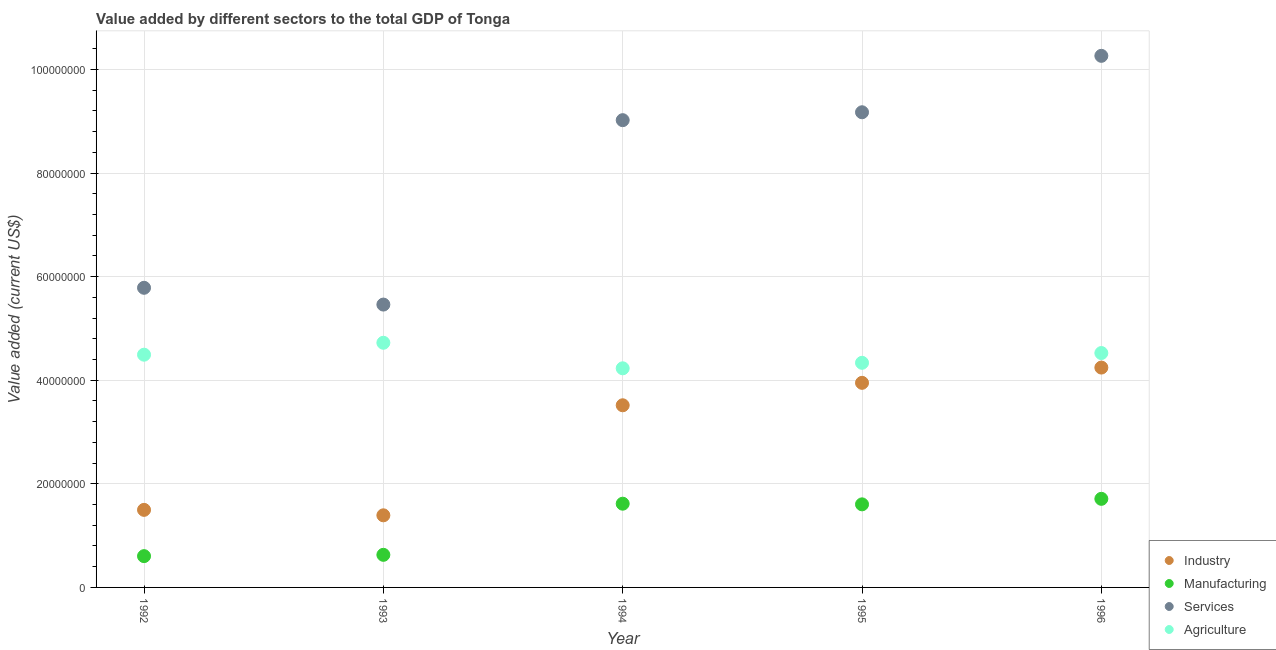How many different coloured dotlines are there?
Keep it short and to the point. 4. What is the value added by manufacturing sector in 1992?
Provide a short and direct response. 6.04e+06. Across all years, what is the maximum value added by industrial sector?
Offer a terse response. 4.25e+07. Across all years, what is the minimum value added by industrial sector?
Provide a succinct answer. 1.39e+07. What is the total value added by manufacturing sector in the graph?
Ensure brevity in your answer.  6.16e+07. What is the difference between the value added by industrial sector in 1993 and that in 1996?
Make the answer very short. -2.85e+07. What is the difference between the value added by services sector in 1996 and the value added by manufacturing sector in 1995?
Offer a terse response. 8.66e+07. What is the average value added by services sector per year?
Your answer should be very brief. 7.94e+07. In the year 1992, what is the difference between the value added by agricultural sector and value added by services sector?
Provide a short and direct response. -1.29e+07. In how many years, is the value added by manufacturing sector greater than 20000000 US$?
Provide a succinct answer. 0. What is the ratio of the value added by industrial sector in 1993 to that in 1994?
Provide a short and direct response. 0.4. Is the value added by agricultural sector in 1992 less than that in 1995?
Offer a terse response. No. Is the difference between the value added by manufacturing sector in 1992 and 1995 greater than the difference between the value added by services sector in 1992 and 1995?
Your answer should be very brief. Yes. What is the difference between the highest and the second highest value added by agricultural sector?
Provide a short and direct response. 1.98e+06. What is the difference between the highest and the lowest value added by industrial sector?
Provide a short and direct response. 2.85e+07. Is the sum of the value added by manufacturing sector in 1992 and 1994 greater than the maximum value added by agricultural sector across all years?
Ensure brevity in your answer.  No. Is it the case that in every year, the sum of the value added by services sector and value added by industrial sector is greater than the sum of value added by agricultural sector and value added by manufacturing sector?
Offer a terse response. No. Is it the case that in every year, the sum of the value added by industrial sector and value added by manufacturing sector is greater than the value added by services sector?
Offer a terse response. No. Is the value added by services sector strictly greater than the value added by industrial sector over the years?
Your answer should be very brief. Yes. Does the graph contain any zero values?
Your answer should be compact. No. Where does the legend appear in the graph?
Give a very brief answer. Bottom right. What is the title of the graph?
Give a very brief answer. Value added by different sectors to the total GDP of Tonga. Does "Second 20% of population" appear as one of the legend labels in the graph?
Provide a succinct answer. No. What is the label or title of the X-axis?
Ensure brevity in your answer.  Year. What is the label or title of the Y-axis?
Offer a terse response. Value added (current US$). What is the Value added (current US$) in Industry in 1992?
Your response must be concise. 1.50e+07. What is the Value added (current US$) in Manufacturing in 1992?
Provide a succinct answer. 6.04e+06. What is the Value added (current US$) of Services in 1992?
Provide a succinct answer. 5.79e+07. What is the Value added (current US$) of Agriculture in 1992?
Your answer should be compact. 4.49e+07. What is the Value added (current US$) of Industry in 1993?
Provide a succinct answer. 1.39e+07. What is the Value added (current US$) of Manufacturing in 1993?
Make the answer very short. 6.29e+06. What is the Value added (current US$) of Services in 1993?
Your answer should be very brief. 5.46e+07. What is the Value added (current US$) in Agriculture in 1993?
Offer a very short reply. 4.72e+07. What is the Value added (current US$) of Industry in 1994?
Ensure brevity in your answer.  3.52e+07. What is the Value added (current US$) of Manufacturing in 1994?
Your response must be concise. 1.62e+07. What is the Value added (current US$) in Services in 1994?
Ensure brevity in your answer.  9.02e+07. What is the Value added (current US$) of Agriculture in 1994?
Offer a terse response. 4.23e+07. What is the Value added (current US$) of Industry in 1995?
Keep it short and to the point. 3.95e+07. What is the Value added (current US$) of Manufacturing in 1995?
Your response must be concise. 1.60e+07. What is the Value added (current US$) of Services in 1995?
Provide a short and direct response. 9.17e+07. What is the Value added (current US$) in Agriculture in 1995?
Provide a succinct answer. 4.34e+07. What is the Value added (current US$) in Industry in 1996?
Your answer should be compact. 4.25e+07. What is the Value added (current US$) of Manufacturing in 1996?
Your answer should be very brief. 1.71e+07. What is the Value added (current US$) of Services in 1996?
Your response must be concise. 1.03e+08. What is the Value added (current US$) of Agriculture in 1996?
Your response must be concise. 4.53e+07. Across all years, what is the maximum Value added (current US$) in Industry?
Your answer should be compact. 4.25e+07. Across all years, what is the maximum Value added (current US$) of Manufacturing?
Give a very brief answer. 1.71e+07. Across all years, what is the maximum Value added (current US$) of Services?
Your answer should be compact. 1.03e+08. Across all years, what is the maximum Value added (current US$) of Agriculture?
Offer a very short reply. 4.72e+07. Across all years, what is the minimum Value added (current US$) in Industry?
Your response must be concise. 1.39e+07. Across all years, what is the minimum Value added (current US$) of Manufacturing?
Your response must be concise. 6.04e+06. Across all years, what is the minimum Value added (current US$) in Services?
Offer a very short reply. 5.46e+07. Across all years, what is the minimum Value added (current US$) of Agriculture?
Give a very brief answer. 4.23e+07. What is the total Value added (current US$) in Industry in the graph?
Provide a short and direct response. 1.46e+08. What is the total Value added (current US$) in Manufacturing in the graph?
Your answer should be compact. 6.16e+07. What is the total Value added (current US$) in Services in the graph?
Your response must be concise. 3.97e+08. What is the total Value added (current US$) in Agriculture in the graph?
Provide a short and direct response. 2.23e+08. What is the difference between the Value added (current US$) of Industry in 1992 and that in 1993?
Offer a terse response. 1.05e+06. What is the difference between the Value added (current US$) of Manufacturing in 1992 and that in 1993?
Offer a terse response. -2.51e+05. What is the difference between the Value added (current US$) of Services in 1992 and that in 1993?
Offer a very short reply. 3.24e+06. What is the difference between the Value added (current US$) in Agriculture in 1992 and that in 1993?
Provide a succinct answer. -2.30e+06. What is the difference between the Value added (current US$) of Industry in 1992 and that in 1994?
Provide a succinct answer. -2.02e+07. What is the difference between the Value added (current US$) in Manufacturing in 1992 and that in 1994?
Give a very brief answer. -1.01e+07. What is the difference between the Value added (current US$) of Services in 1992 and that in 1994?
Make the answer very short. -3.24e+07. What is the difference between the Value added (current US$) in Agriculture in 1992 and that in 1994?
Your answer should be very brief. 2.63e+06. What is the difference between the Value added (current US$) in Industry in 1992 and that in 1995?
Provide a short and direct response. -2.45e+07. What is the difference between the Value added (current US$) in Manufacturing in 1992 and that in 1995?
Give a very brief answer. -1.00e+07. What is the difference between the Value added (current US$) in Services in 1992 and that in 1995?
Your response must be concise. -3.39e+07. What is the difference between the Value added (current US$) in Agriculture in 1992 and that in 1995?
Provide a succinct answer. 1.57e+06. What is the difference between the Value added (current US$) of Industry in 1992 and that in 1996?
Ensure brevity in your answer.  -2.75e+07. What is the difference between the Value added (current US$) of Manufacturing in 1992 and that in 1996?
Provide a succinct answer. -1.11e+07. What is the difference between the Value added (current US$) of Services in 1992 and that in 1996?
Provide a succinct answer. -4.48e+07. What is the difference between the Value added (current US$) of Agriculture in 1992 and that in 1996?
Offer a terse response. -3.18e+05. What is the difference between the Value added (current US$) in Industry in 1993 and that in 1994?
Your answer should be compact. -2.12e+07. What is the difference between the Value added (current US$) in Manufacturing in 1993 and that in 1994?
Provide a succinct answer. -9.87e+06. What is the difference between the Value added (current US$) in Services in 1993 and that in 1994?
Your answer should be very brief. -3.56e+07. What is the difference between the Value added (current US$) in Agriculture in 1993 and that in 1994?
Your answer should be compact. 4.93e+06. What is the difference between the Value added (current US$) in Industry in 1993 and that in 1995?
Your answer should be very brief. -2.56e+07. What is the difference between the Value added (current US$) in Manufacturing in 1993 and that in 1995?
Your response must be concise. -9.75e+06. What is the difference between the Value added (current US$) in Services in 1993 and that in 1995?
Your answer should be compact. -3.71e+07. What is the difference between the Value added (current US$) of Agriculture in 1993 and that in 1995?
Make the answer very short. 3.87e+06. What is the difference between the Value added (current US$) of Industry in 1993 and that in 1996?
Keep it short and to the point. -2.85e+07. What is the difference between the Value added (current US$) in Manufacturing in 1993 and that in 1996?
Your response must be concise. -1.08e+07. What is the difference between the Value added (current US$) in Services in 1993 and that in 1996?
Give a very brief answer. -4.80e+07. What is the difference between the Value added (current US$) of Agriculture in 1993 and that in 1996?
Offer a very short reply. 1.98e+06. What is the difference between the Value added (current US$) of Industry in 1994 and that in 1995?
Ensure brevity in your answer.  -4.33e+06. What is the difference between the Value added (current US$) in Manufacturing in 1994 and that in 1995?
Your answer should be very brief. 1.26e+05. What is the difference between the Value added (current US$) of Services in 1994 and that in 1995?
Your response must be concise. -1.53e+06. What is the difference between the Value added (current US$) of Agriculture in 1994 and that in 1995?
Make the answer very short. -1.06e+06. What is the difference between the Value added (current US$) in Industry in 1994 and that in 1996?
Your answer should be very brief. -7.28e+06. What is the difference between the Value added (current US$) in Manufacturing in 1994 and that in 1996?
Provide a succinct answer. -9.40e+05. What is the difference between the Value added (current US$) in Services in 1994 and that in 1996?
Provide a succinct answer. -1.24e+07. What is the difference between the Value added (current US$) in Agriculture in 1994 and that in 1996?
Ensure brevity in your answer.  -2.95e+06. What is the difference between the Value added (current US$) in Industry in 1995 and that in 1996?
Your response must be concise. -2.95e+06. What is the difference between the Value added (current US$) in Manufacturing in 1995 and that in 1996?
Ensure brevity in your answer.  -1.07e+06. What is the difference between the Value added (current US$) of Services in 1995 and that in 1996?
Make the answer very short. -1.09e+07. What is the difference between the Value added (current US$) of Agriculture in 1995 and that in 1996?
Provide a succinct answer. -1.89e+06. What is the difference between the Value added (current US$) in Industry in 1992 and the Value added (current US$) in Manufacturing in 1993?
Provide a short and direct response. 8.68e+06. What is the difference between the Value added (current US$) in Industry in 1992 and the Value added (current US$) in Services in 1993?
Keep it short and to the point. -3.96e+07. What is the difference between the Value added (current US$) of Industry in 1992 and the Value added (current US$) of Agriculture in 1993?
Ensure brevity in your answer.  -3.23e+07. What is the difference between the Value added (current US$) of Manufacturing in 1992 and the Value added (current US$) of Services in 1993?
Your answer should be very brief. -4.86e+07. What is the difference between the Value added (current US$) of Manufacturing in 1992 and the Value added (current US$) of Agriculture in 1993?
Ensure brevity in your answer.  -4.12e+07. What is the difference between the Value added (current US$) in Services in 1992 and the Value added (current US$) in Agriculture in 1993?
Keep it short and to the point. 1.06e+07. What is the difference between the Value added (current US$) in Industry in 1992 and the Value added (current US$) in Manufacturing in 1994?
Offer a very short reply. -1.19e+06. What is the difference between the Value added (current US$) in Industry in 1992 and the Value added (current US$) in Services in 1994?
Your answer should be very brief. -7.52e+07. What is the difference between the Value added (current US$) in Industry in 1992 and the Value added (current US$) in Agriculture in 1994?
Your answer should be very brief. -2.73e+07. What is the difference between the Value added (current US$) in Manufacturing in 1992 and the Value added (current US$) in Services in 1994?
Your response must be concise. -8.42e+07. What is the difference between the Value added (current US$) of Manufacturing in 1992 and the Value added (current US$) of Agriculture in 1994?
Make the answer very short. -3.63e+07. What is the difference between the Value added (current US$) of Services in 1992 and the Value added (current US$) of Agriculture in 1994?
Give a very brief answer. 1.55e+07. What is the difference between the Value added (current US$) in Industry in 1992 and the Value added (current US$) in Manufacturing in 1995?
Provide a short and direct response. -1.06e+06. What is the difference between the Value added (current US$) in Industry in 1992 and the Value added (current US$) in Services in 1995?
Your answer should be very brief. -7.68e+07. What is the difference between the Value added (current US$) of Industry in 1992 and the Value added (current US$) of Agriculture in 1995?
Ensure brevity in your answer.  -2.84e+07. What is the difference between the Value added (current US$) of Manufacturing in 1992 and the Value added (current US$) of Services in 1995?
Your response must be concise. -8.57e+07. What is the difference between the Value added (current US$) in Manufacturing in 1992 and the Value added (current US$) in Agriculture in 1995?
Ensure brevity in your answer.  -3.73e+07. What is the difference between the Value added (current US$) in Services in 1992 and the Value added (current US$) in Agriculture in 1995?
Your answer should be compact. 1.45e+07. What is the difference between the Value added (current US$) in Industry in 1992 and the Value added (current US$) in Manufacturing in 1996?
Your answer should be very brief. -2.13e+06. What is the difference between the Value added (current US$) in Industry in 1992 and the Value added (current US$) in Services in 1996?
Offer a terse response. -8.77e+07. What is the difference between the Value added (current US$) of Industry in 1992 and the Value added (current US$) of Agriculture in 1996?
Provide a short and direct response. -3.03e+07. What is the difference between the Value added (current US$) in Manufacturing in 1992 and the Value added (current US$) in Services in 1996?
Offer a very short reply. -9.66e+07. What is the difference between the Value added (current US$) of Manufacturing in 1992 and the Value added (current US$) of Agriculture in 1996?
Offer a very short reply. -3.92e+07. What is the difference between the Value added (current US$) of Services in 1992 and the Value added (current US$) of Agriculture in 1996?
Keep it short and to the point. 1.26e+07. What is the difference between the Value added (current US$) in Industry in 1993 and the Value added (current US$) in Manufacturing in 1994?
Ensure brevity in your answer.  -2.24e+06. What is the difference between the Value added (current US$) of Industry in 1993 and the Value added (current US$) of Services in 1994?
Keep it short and to the point. -7.63e+07. What is the difference between the Value added (current US$) in Industry in 1993 and the Value added (current US$) in Agriculture in 1994?
Offer a very short reply. -2.84e+07. What is the difference between the Value added (current US$) of Manufacturing in 1993 and the Value added (current US$) of Services in 1994?
Keep it short and to the point. -8.39e+07. What is the difference between the Value added (current US$) in Manufacturing in 1993 and the Value added (current US$) in Agriculture in 1994?
Keep it short and to the point. -3.60e+07. What is the difference between the Value added (current US$) in Services in 1993 and the Value added (current US$) in Agriculture in 1994?
Ensure brevity in your answer.  1.23e+07. What is the difference between the Value added (current US$) in Industry in 1993 and the Value added (current US$) in Manufacturing in 1995?
Offer a very short reply. -2.12e+06. What is the difference between the Value added (current US$) of Industry in 1993 and the Value added (current US$) of Services in 1995?
Offer a very short reply. -7.78e+07. What is the difference between the Value added (current US$) of Industry in 1993 and the Value added (current US$) of Agriculture in 1995?
Your answer should be very brief. -2.94e+07. What is the difference between the Value added (current US$) of Manufacturing in 1993 and the Value added (current US$) of Services in 1995?
Make the answer very short. -8.55e+07. What is the difference between the Value added (current US$) in Manufacturing in 1993 and the Value added (current US$) in Agriculture in 1995?
Offer a terse response. -3.71e+07. What is the difference between the Value added (current US$) in Services in 1993 and the Value added (current US$) in Agriculture in 1995?
Your answer should be very brief. 1.12e+07. What is the difference between the Value added (current US$) of Industry in 1993 and the Value added (current US$) of Manufacturing in 1996?
Give a very brief answer. -3.18e+06. What is the difference between the Value added (current US$) of Industry in 1993 and the Value added (current US$) of Services in 1996?
Keep it short and to the point. -8.87e+07. What is the difference between the Value added (current US$) in Industry in 1993 and the Value added (current US$) in Agriculture in 1996?
Provide a succinct answer. -3.13e+07. What is the difference between the Value added (current US$) of Manufacturing in 1993 and the Value added (current US$) of Services in 1996?
Provide a succinct answer. -9.63e+07. What is the difference between the Value added (current US$) in Manufacturing in 1993 and the Value added (current US$) in Agriculture in 1996?
Your answer should be very brief. -3.90e+07. What is the difference between the Value added (current US$) in Services in 1993 and the Value added (current US$) in Agriculture in 1996?
Provide a succinct answer. 9.36e+06. What is the difference between the Value added (current US$) in Industry in 1994 and the Value added (current US$) in Manufacturing in 1995?
Offer a very short reply. 1.91e+07. What is the difference between the Value added (current US$) in Industry in 1994 and the Value added (current US$) in Services in 1995?
Make the answer very short. -5.66e+07. What is the difference between the Value added (current US$) of Industry in 1994 and the Value added (current US$) of Agriculture in 1995?
Give a very brief answer. -8.20e+06. What is the difference between the Value added (current US$) of Manufacturing in 1994 and the Value added (current US$) of Services in 1995?
Your response must be concise. -7.56e+07. What is the difference between the Value added (current US$) of Manufacturing in 1994 and the Value added (current US$) of Agriculture in 1995?
Give a very brief answer. -2.72e+07. What is the difference between the Value added (current US$) in Services in 1994 and the Value added (current US$) in Agriculture in 1995?
Your response must be concise. 4.69e+07. What is the difference between the Value added (current US$) in Industry in 1994 and the Value added (current US$) in Manufacturing in 1996?
Ensure brevity in your answer.  1.81e+07. What is the difference between the Value added (current US$) in Industry in 1994 and the Value added (current US$) in Services in 1996?
Provide a succinct answer. -6.75e+07. What is the difference between the Value added (current US$) of Industry in 1994 and the Value added (current US$) of Agriculture in 1996?
Ensure brevity in your answer.  -1.01e+07. What is the difference between the Value added (current US$) of Manufacturing in 1994 and the Value added (current US$) of Services in 1996?
Give a very brief answer. -8.65e+07. What is the difference between the Value added (current US$) of Manufacturing in 1994 and the Value added (current US$) of Agriculture in 1996?
Give a very brief answer. -2.91e+07. What is the difference between the Value added (current US$) of Services in 1994 and the Value added (current US$) of Agriculture in 1996?
Your response must be concise. 4.50e+07. What is the difference between the Value added (current US$) of Industry in 1995 and the Value added (current US$) of Manufacturing in 1996?
Your response must be concise. 2.24e+07. What is the difference between the Value added (current US$) in Industry in 1995 and the Value added (current US$) in Services in 1996?
Make the answer very short. -6.31e+07. What is the difference between the Value added (current US$) of Industry in 1995 and the Value added (current US$) of Agriculture in 1996?
Offer a terse response. -5.75e+06. What is the difference between the Value added (current US$) of Manufacturing in 1995 and the Value added (current US$) of Services in 1996?
Provide a succinct answer. -8.66e+07. What is the difference between the Value added (current US$) of Manufacturing in 1995 and the Value added (current US$) of Agriculture in 1996?
Ensure brevity in your answer.  -2.92e+07. What is the difference between the Value added (current US$) of Services in 1995 and the Value added (current US$) of Agriculture in 1996?
Offer a terse response. 4.65e+07. What is the average Value added (current US$) of Industry per year?
Ensure brevity in your answer.  2.92e+07. What is the average Value added (current US$) of Manufacturing per year?
Your answer should be compact. 1.23e+07. What is the average Value added (current US$) of Services per year?
Make the answer very short. 7.94e+07. What is the average Value added (current US$) in Agriculture per year?
Keep it short and to the point. 4.46e+07. In the year 1992, what is the difference between the Value added (current US$) in Industry and Value added (current US$) in Manufacturing?
Make the answer very short. 8.93e+06. In the year 1992, what is the difference between the Value added (current US$) in Industry and Value added (current US$) in Services?
Make the answer very short. -4.29e+07. In the year 1992, what is the difference between the Value added (current US$) in Industry and Value added (current US$) in Agriculture?
Provide a succinct answer. -3.00e+07. In the year 1992, what is the difference between the Value added (current US$) of Manufacturing and Value added (current US$) of Services?
Ensure brevity in your answer.  -5.18e+07. In the year 1992, what is the difference between the Value added (current US$) in Manufacturing and Value added (current US$) in Agriculture?
Ensure brevity in your answer.  -3.89e+07. In the year 1992, what is the difference between the Value added (current US$) in Services and Value added (current US$) in Agriculture?
Offer a very short reply. 1.29e+07. In the year 1993, what is the difference between the Value added (current US$) in Industry and Value added (current US$) in Manufacturing?
Provide a succinct answer. 7.63e+06. In the year 1993, what is the difference between the Value added (current US$) in Industry and Value added (current US$) in Services?
Offer a terse response. -4.07e+07. In the year 1993, what is the difference between the Value added (current US$) in Industry and Value added (current US$) in Agriculture?
Provide a short and direct response. -3.33e+07. In the year 1993, what is the difference between the Value added (current US$) of Manufacturing and Value added (current US$) of Services?
Give a very brief answer. -4.83e+07. In the year 1993, what is the difference between the Value added (current US$) in Manufacturing and Value added (current US$) in Agriculture?
Provide a succinct answer. -4.09e+07. In the year 1993, what is the difference between the Value added (current US$) of Services and Value added (current US$) of Agriculture?
Offer a terse response. 7.38e+06. In the year 1994, what is the difference between the Value added (current US$) in Industry and Value added (current US$) in Manufacturing?
Your response must be concise. 1.90e+07. In the year 1994, what is the difference between the Value added (current US$) of Industry and Value added (current US$) of Services?
Make the answer very short. -5.51e+07. In the year 1994, what is the difference between the Value added (current US$) of Industry and Value added (current US$) of Agriculture?
Your response must be concise. -7.14e+06. In the year 1994, what is the difference between the Value added (current US$) of Manufacturing and Value added (current US$) of Services?
Ensure brevity in your answer.  -7.41e+07. In the year 1994, what is the difference between the Value added (current US$) in Manufacturing and Value added (current US$) in Agriculture?
Provide a succinct answer. -2.61e+07. In the year 1994, what is the difference between the Value added (current US$) of Services and Value added (current US$) of Agriculture?
Provide a short and direct response. 4.79e+07. In the year 1995, what is the difference between the Value added (current US$) of Industry and Value added (current US$) of Manufacturing?
Keep it short and to the point. 2.35e+07. In the year 1995, what is the difference between the Value added (current US$) of Industry and Value added (current US$) of Services?
Your answer should be very brief. -5.22e+07. In the year 1995, what is the difference between the Value added (current US$) of Industry and Value added (current US$) of Agriculture?
Ensure brevity in your answer.  -3.87e+06. In the year 1995, what is the difference between the Value added (current US$) in Manufacturing and Value added (current US$) in Services?
Provide a succinct answer. -7.57e+07. In the year 1995, what is the difference between the Value added (current US$) of Manufacturing and Value added (current US$) of Agriculture?
Offer a very short reply. -2.73e+07. In the year 1995, what is the difference between the Value added (current US$) of Services and Value added (current US$) of Agriculture?
Keep it short and to the point. 4.84e+07. In the year 1996, what is the difference between the Value added (current US$) in Industry and Value added (current US$) in Manufacturing?
Provide a short and direct response. 2.53e+07. In the year 1996, what is the difference between the Value added (current US$) of Industry and Value added (current US$) of Services?
Offer a very short reply. -6.02e+07. In the year 1996, what is the difference between the Value added (current US$) of Industry and Value added (current US$) of Agriculture?
Provide a short and direct response. -2.80e+06. In the year 1996, what is the difference between the Value added (current US$) in Manufacturing and Value added (current US$) in Services?
Keep it short and to the point. -8.55e+07. In the year 1996, what is the difference between the Value added (current US$) of Manufacturing and Value added (current US$) of Agriculture?
Offer a very short reply. -2.82e+07. In the year 1996, what is the difference between the Value added (current US$) of Services and Value added (current US$) of Agriculture?
Keep it short and to the point. 5.74e+07. What is the ratio of the Value added (current US$) in Industry in 1992 to that in 1993?
Your answer should be very brief. 1.08. What is the ratio of the Value added (current US$) in Manufacturing in 1992 to that in 1993?
Offer a terse response. 0.96. What is the ratio of the Value added (current US$) in Services in 1992 to that in 1993?
Your answer should be very brief. 1.06. What is the ratio of the Value added (current US$) of Agriculture in 1992 to that in 1993?
Provide a succinct answer. 0.95. What is the ratio of the Value added (current US$) in Industry in 1992 to that in 1994?
Provide a succinct answer. 0.43. What is the ratio of the Value added (current US$) in Manufacturing in 1992 to that in 1994?
Ensure brevity in your answer.  0.37. What is the ratio of the Value added (current US$) in Services in 1992 to that in 1994?
Ensure brevity in your answer.  0.64. What is the ratio of the Value added (current US$) in Agriculture in 1992 to that in 1994?
Provide a short and direct response. 1.06. What is the ratio of the Value added (current US$) in Industry in 1992 to that in 1995?
Provide a short and direct response. 0.38. What is the ratio of the Value added (current US$) in Manufacturing in 1992 to that in 1995?
Your response must be concise. 0.38. What is the ratio of the Value added (current US$) in Services in 1992 to that in 1995?
Keep it short and to the point. 0.63. What is the ratio of the Value added (current US$) in Agriculture in 1992 to that in 1995?
Offer a terse response. 1.04. What is the ratio of the Value added (current US$) of Industry in 1992 to that in 1996?
Give a very brief answer. 0.35. What is the ratio of the Value added (current US$) of Manufacturing in 1992 to that in 1996?
Your answer should be compact. 0.35. What is the ratio of the Value added (current US$) of Services in 1992 to that in 1996?
Ensure brevity in your answer.  0.56. What is the ratio of the Value added (current US$) of Agriculture in 1992 to that in 1996?
Provide a short and direct response. 0.99. What is the ratio of the Value added (current US$) in Industry in 1993 to that in 1994?
Provide a succinct answer. 0.4. What is the ratio of the Value added (current US$) in Manufacturing in 1993 to that in 1994?
Ensure brevity in your answer.  0.39. What is the ratio of the Value added (current US$) in Services in 1993 to that in 1994?
Keep it short and to the point. 0.61. What is the ratio of the Value added (current US$) of Agriculture in 1993 to that in 1994?
Provide a short and direct response. 1.12. What is the ratio of the Value added (current US$) of Industry in 1993 to that in 1995?
Keep it short and to the point. 0.35. What is the ratio of the Value added (current US$) of Manufacturing in 1993 to that in 1995?
Make the answer very short. 0.39. What is the ratio of the Value added (current US$) in Services in 1993 to that in 1995?
Ensure brevity in your answer.  0.6. What is the ratio of the Value added (current US$) in Agriculture in 1993 to that in 1995?
Offer a very short reply. 1.09. What is the ratio of the Value added (current US$) in Industry in 1993 to that in 1996?
Your response must be concise. 0.33. What is the ratio of the Value added (current US$) in Manufacturing in 1993 to that in 1996?
Offer a very short reply. 0.37. What is the ratio of the Value added (current US$) of Services in 1993 to that in 1996?
Offer a terse response. 0.53. What is the ratio of the Value added (current US$) of Agriculture in 1993 to that in 1996?
Provide a short and direct response. 1.04. What is the ratio of the Value added (current US$) of Industry in 1994 to that in 1995?
Make the answer very short. 0.89. What is the ratio of the Value added (current US$) in Manufacturing in 1994 to that in 1995?
Offer a terse response. 1.01. What is the ratio of the Value added (current US$) in Services in 1994 to that in 1995?
Keep it short and to the point. 0.98. What is the ratio of the Value added (current US$) of Agriculture in 1994 to that in 1995?
Ensure brevity in your answer.  0.98. What is the ratio of the Value added (current US$) in Industry in 1994 to that in 1996?
Give a very brief answer. 0.83. What is the ratio of the Value added (current US$) of Manufacturing in 1994 to that in 1996?
Make the answer very short. 0.95. What is the ratio of the Value added (current US$) in Services in 1994 to that in 1996?
Your response must be concise. 0.88. What is the ratio of the Value added (current US$) in Agriculture in 1994 to that in 1996?
Your answer should be very brief. 0.93. What is the ratio of the Value added (current US$) in Industry in 1995 to that in 1996?
Provide a short and direct response. 0.93. What is the ratio of the Value added (current US$) in Manufacturing in 1995 to that in 1996?
Offer a terse response. 0.94. What is the ratio of the Value added (current US$) of Services in 1995 to that in 1996?
Your answer should be very brief. 0.89. What is the difference between the highest and the second highest Value added (current US$) of Industry?
Ensure brevity in your answer.  2.95e+06. What is the difference between the highest and the second highest Value added (current US$) of Manufacturing?
Keep it short and to the point. 9.40e+05. What is the difference between the highest and the second highest Value added (current US$) of Services?
Give a very brief answer. 1.09e+07. What is the difference between the highest and the second highest Value added (current US$) of Agriculture?
Ensure brevity in your answer.  1.98e+06. What is the difference between the highest and the lowest Value added (current US$) of Industry?
Give a very brief answer. 2.85e+07. What is the difference between the highest and the lowest Value added (current US$) in Manufacturing?
Keep it short and to the point. 1.11e+07. What is the difference between the highest and the lowest Value added (current US$) in Services?
Provide a succinct answer. 4.80e+07. What is the difference between the highest and the lowest Value added (current US$) in Agriculture?
Offer a terse response. 4.93e+06. 